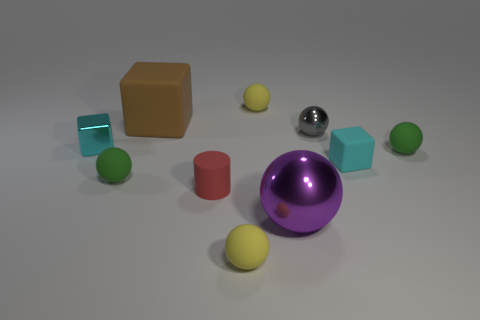Do the small metallic block and the rubber block that is in front of the brown matte block have the same color?
Make the answer very short. Yes. What number of other things are there of the same shape as the tiny gray metallic object?
Make the answer very short. 5. What size is the other cube that is the same color as the tiny metal block?
Your answer should be very brief. Small. There is a tiny object that is left of the cyan matte cube and to the right of the large sphere; what shape is it?
Give a very brief answer. Sphere. Do the small gray thing and the green thing that is left of the small cylinder have the same shape?
Ensure brevity in your answer.  Yes. Are there any matte things in front of the red matte thing?
Your answer should be compact. Yes. What material is the other small block that is the same color as the small metallic block?
Keep it short and to the point. Rubber. How many spheres are tiny gray metallic things or tiny metal objects?
Offer a terse response. 1. Does the gray thing have the same shape as the purple object?
Provide a succinct answer. Yes. There is a matte cube on the left side of the cyan rubber thing; what size is it?
Offer a terse response. Large. 